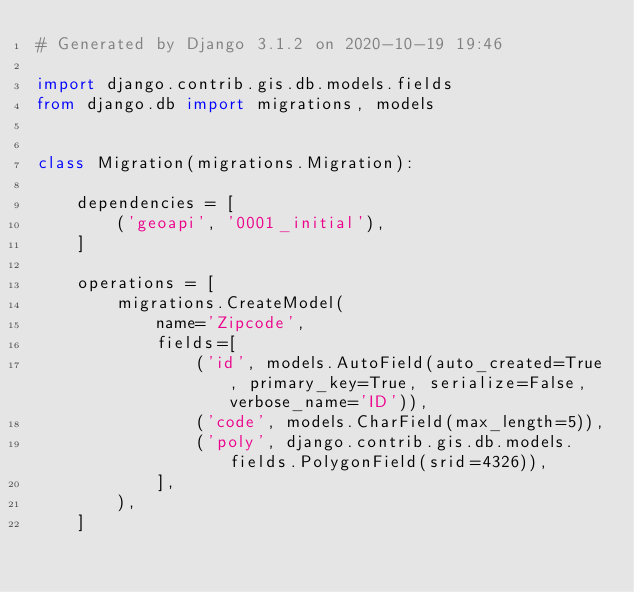Convert code to text. <code><loc_0><loc_0><loc_500><loc_500><_Python_># Generated by Django 3.1.2 on 2020-10-19 19:46

import django.contrib.gis.db.models.fields
from django.db import migrations, models


class Migration(migrations.Migration):

    dependencies = [
        ('geoapi', '0001_initial'),
    ]

    operations = [
        migrations.CreateModel(
            name='Zipcode',
            fields=[
                ('id', models.AutoField(auto_created=True, primary_key=True, serialize=False, verbose_name='ID')),
                ('code', models.CharField(max_length=5)),
                ('poly', django.contrib.gis.db.models.fields.PolygonField(srid=4326)),
            ],
        ),
    ]
</code> 